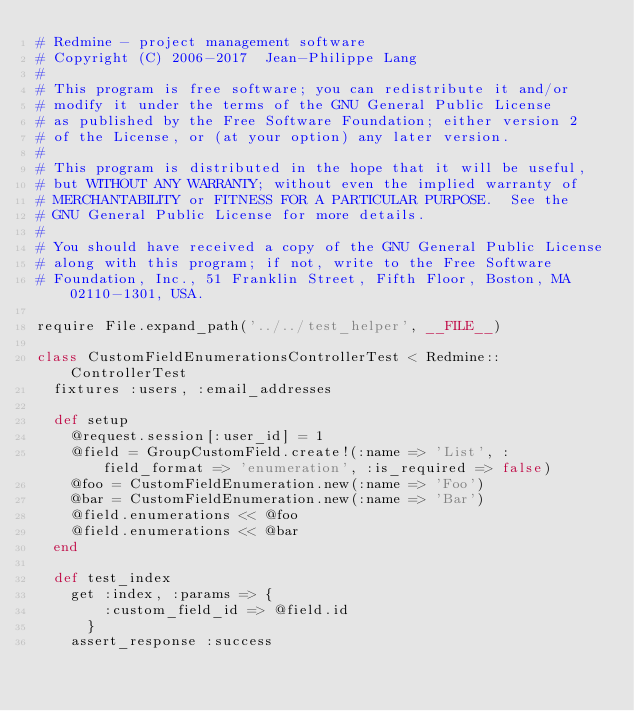Convert code to text. <code><loc_0><loc_0><loc_500><loc_500><_Ruby_># Redmine - project management software
# Copyright (C) 2006-2017  Jean-Philippe Lang
#
# This program is free software; you can redistribute it and/or
# modify it under the terms of the GNU General Public License
# as published by the Free Software Foundation; either version 2
# of the License, or (at your option) any later version.
#
# This program is distributed in the hope that it will be useful,
# but WITHOUT ANY WARRANTY; without even the implied warranty of
# MERCHANTABILITY or FITNESS FOR A PARTICULAR PURPOSE.  See the
# GNU General Public License for more details.
#
# You should have received a copy of the GNU General Public License
# along with this program; if not, write to the Free Software
# Foundation, Inc., 51 Franklin Street, Fifth Floor, Boston, MA  02110-1301, USA.

require File.expand_path('../../test_helper', __FILE__)

class CustomFieldEnumerationsControllerTest < Redmine::ControllerTest
  fixtures :users, :email_addresses

  def setup
    @request.session[:user_id] = 1
    @field = GroupCustomField.create!(:name => 'List', :field_format => 'enumeration', :is_required => false)
    @foo = CustomFieldEnumeration.new(:name => 'Foo')
    @bar = CustomFieldEnumeration.new(:name => 'Bar')
    @field.enumerations << @foo
    @field.enumerations << @bar
  end

  def test_index
    get :index, :params => {
        :custom_field_id => @field.id
      }
    assert_response :success
</code> 